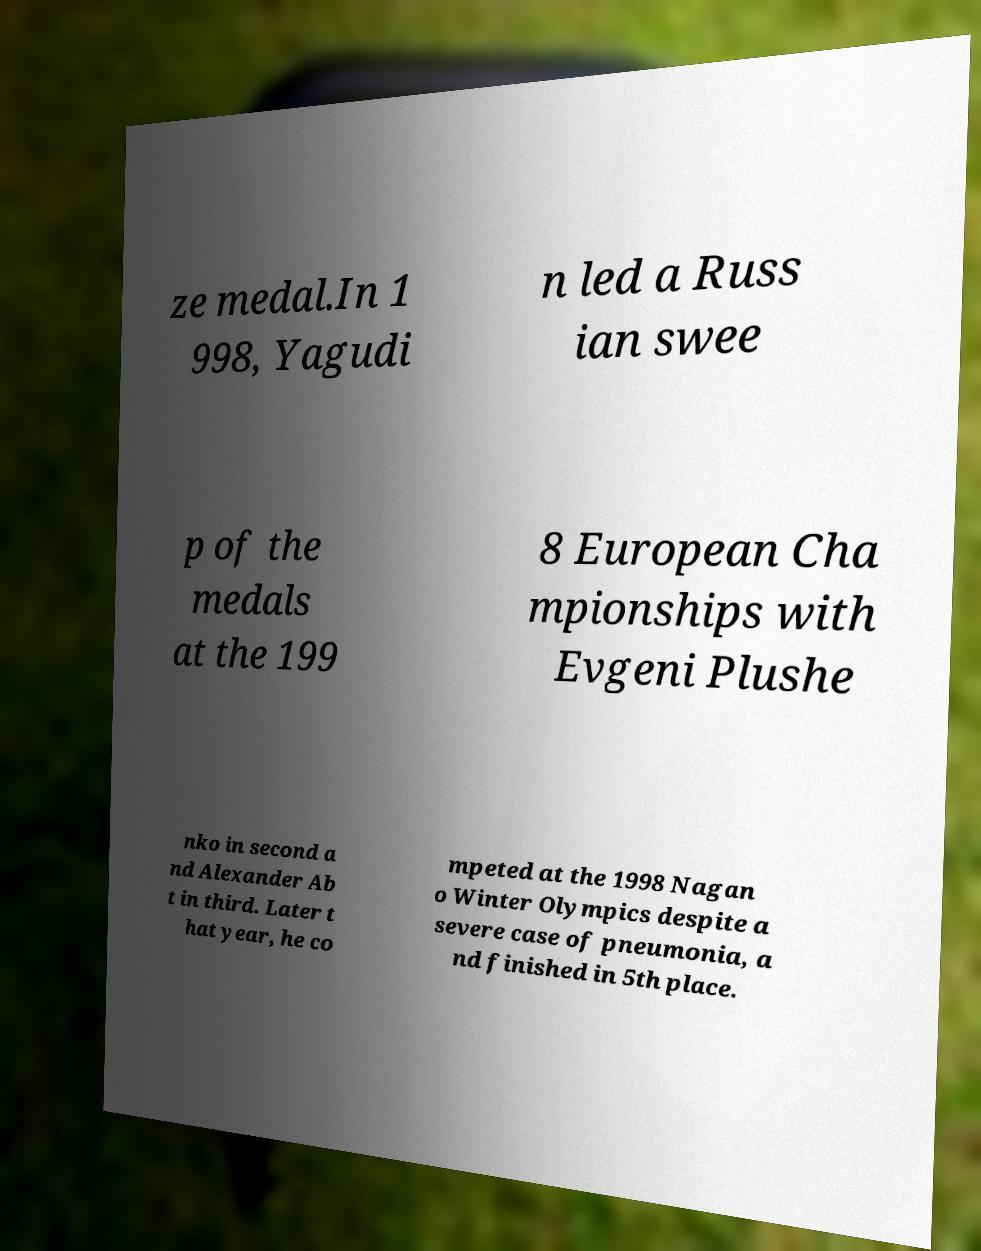Please read and relay the text visible in this image. What does it say? ze medal.In 1 998, Yagudi n led a Russ ian swee p of the medals at the 199 8 European Cha mpionships with Evgeni Plushe nko in second a nd Alexander Ab t in third. Later t hat year, he co mpeted at the 1998 Nagan o Winter Olympics despite a severe case of pneumonia, a nd finished in 5th place. 